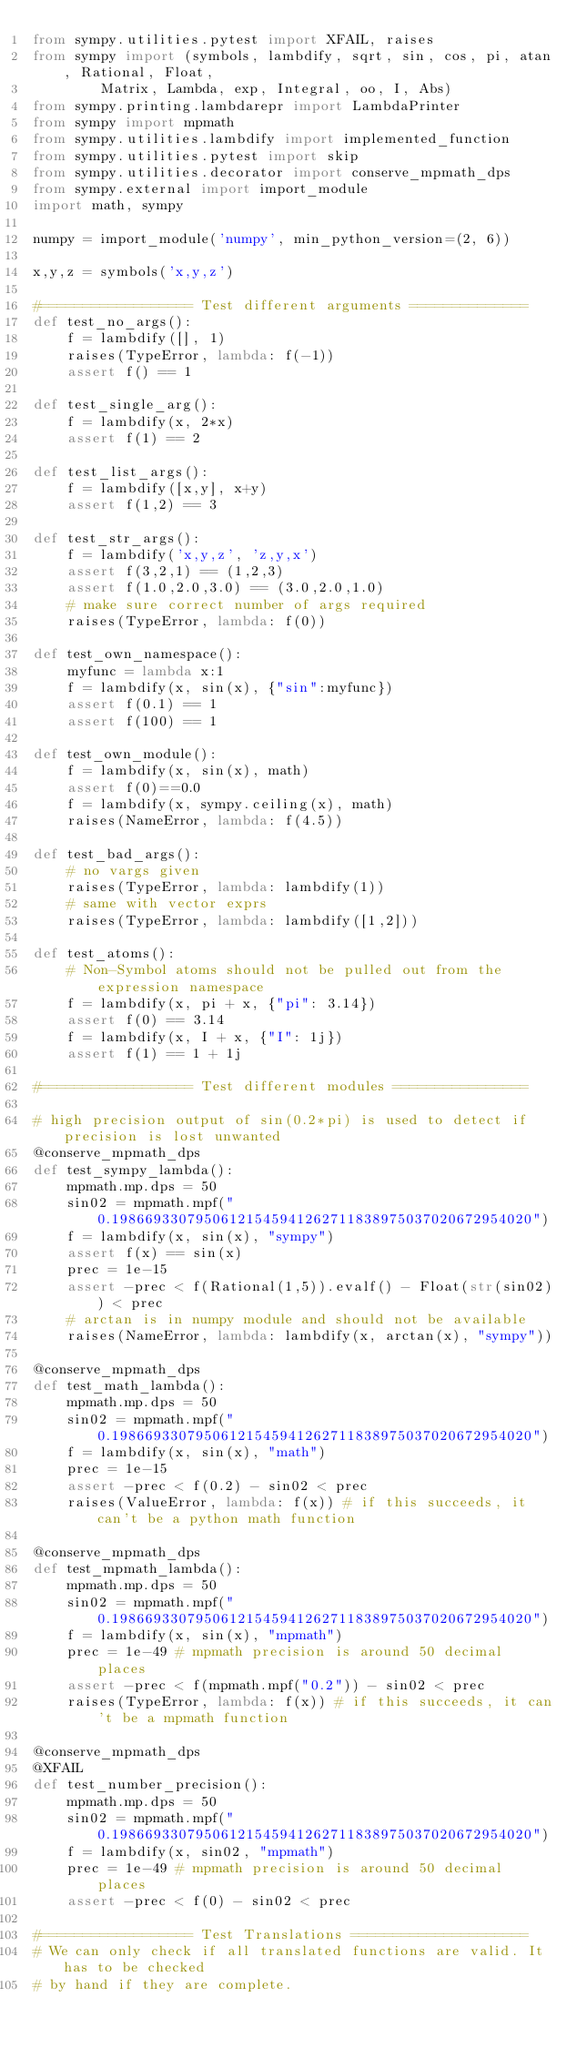Convert code to text. <code><loc_0><loc_0><loc_500><loc_500><_Python_>from sympy.utilities.pytest import XFAIL, raises
from sympy import (symbols, lambdify, sqrt, sin, cos, pi, atan, Rational, Float,
        Matrix, Lambda, exp, Integral, oo, I, Abs)
from sympy.printing.lambdarepr import LambdaPrinter
from sympy import mpmath
from sympy.utilities.lambdify import implemented_function
from sympy.utilities.pytest import skip
from sympy.utilities.decorator import conserve_mpmath_dps
from sympy.external import import_module
import math, sympy

numpy = import_module('numpy', min_python_version=(2, 6))

x,y,z = symbols('x,y,z')

#================== Test different arguments ==============
def test_no_args():
    f = lambdify([], 1)
    raises(TypeError, lambda: f(-1))
    assert f() == 1

def test_single_arg():
    f = lambdify(x, 2*x)
    assert f(1) == 2

def test_list_args():
    f = lambdify([x,y], x+y)
    assert f(1,2) == 3

def test_str_args():
    f = lambdify('x,y,z', 'z,y,x')
    assert f(3,2,1) == (1,2,3)
    assert f(1.0,2.0,3.0) == (3.0,2.0,1.0)
    # make sure correct number of args required
    raises(TypeError, lambda: f(0))

def test_own_namespace():
    myfunc = lambda x:1
    f = lambdify(x, sin(x), {"sin":myfunc})
    assert f(0.1) == 1
    assert f(100) == 1

def test_own_module():
    f = lambdify(x, sin(x), math)
    assert f(0)==0.0
    f = lambdify(x, sympy.ceiling(x), math)
    raises(NameError, lambda: f(4.5))

def test_bad_args():
    # no vargs given
    raises(TypeError, lambda: lambdify(1))
    # same with vector exprs
    raises(TypeError, lambda: lambdify([1,2]))

def test_atoms():
    # Non-Symbol atoms should not be pulled out from the expression namespace
    f = lambdify(x, pi + x, {"pi": 3.14})
    assert f(0) == 3.14
    f = lambdify(x, I + x, {"I": 1j})
    assert f(1) == 1 + 1j

#================== Test different modules ================

# high precision output of sin(0.2*pi) is used to detect if precision is lost unwanted
@conserve_mpmath_dps
def test_sympy_lambda():
    mpmath.mp.dps = 50
    sin02 = mpmath.mpf("0.19866933079506121545941262711838975037020672954020")
    f = lambdify(x, sin(x), "sympy")
    assert f(x) == sin(x)
    prec = 1e-15
    assert -prec < f(Rational(1,5)).evalf() - Float(str(sin02)) < prec
    # arctan is in numpy module and should not be available
    raises(NameError, lambda: lambdify(x, arctan(x), "sympy"))

@conserve_mpmath_dps
def test_math_lambda():
    mpmath.mp.dps = 50
    sin02 = mpmath.mpf("0.19866933079506121545941262711838975037020672954020")
    f = lambdify(x, sin(x), "math")
    prec = 1e-15
    assert -prec < f(0.2) - sin02 < prec
    raises(ValueError, lambda: f(x)) # if this succeeds, it can't be a python math function

@conserve_mpmath_dps
def test_mpmath_lambda():
    mpmath.mp.dps = 50
    sin02 = mpmath.mpf("0.19866933079506121545941262711838975037020672954020")
    f = lambdify(x, sin(x), "mpmath")
    prec = 1e-49 # mpmath precision is around 50 decimal places
    assert -prec < f(mpmath.mpf("0.2")) - sin02 < prec
    raises(TypeError, lambda: f(x)) # if this succeeds, it can't be a mpmath function

@conserve_mpmath_dps
@XFAIL
def test_number_precision():
    mpmath.mp.dps = 50
    sin02 = mpmath.mpf("0.19866933079506121545941262711838975037020672954020")
    f = lambdify(x, sin02, "mpmath")
    prec = 1e-49 # mpmath precision is around 50 decimal places
    assert -prec < f(0) - sin02 < prec

#================== Test Translations =====================
# We can only check if all translated functions are valid. It has to be checked
# by hand if they are complete.
</code> 